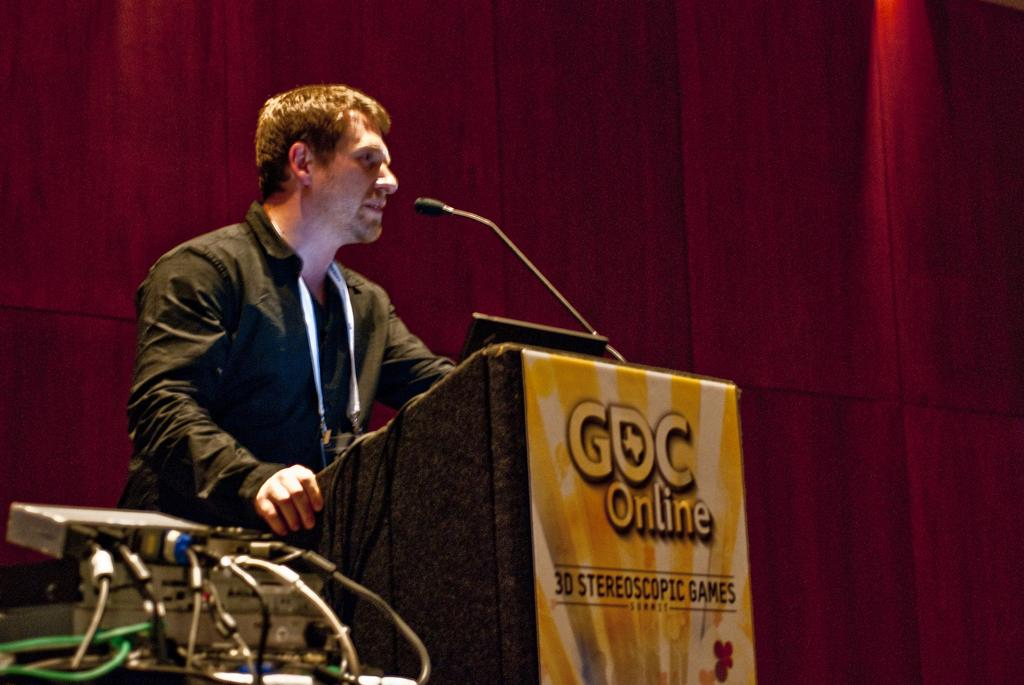<image>
Offer a succinct explanation of the picture presented. A white man stands at a podium with a poster of GDC online on the front of the podium. 